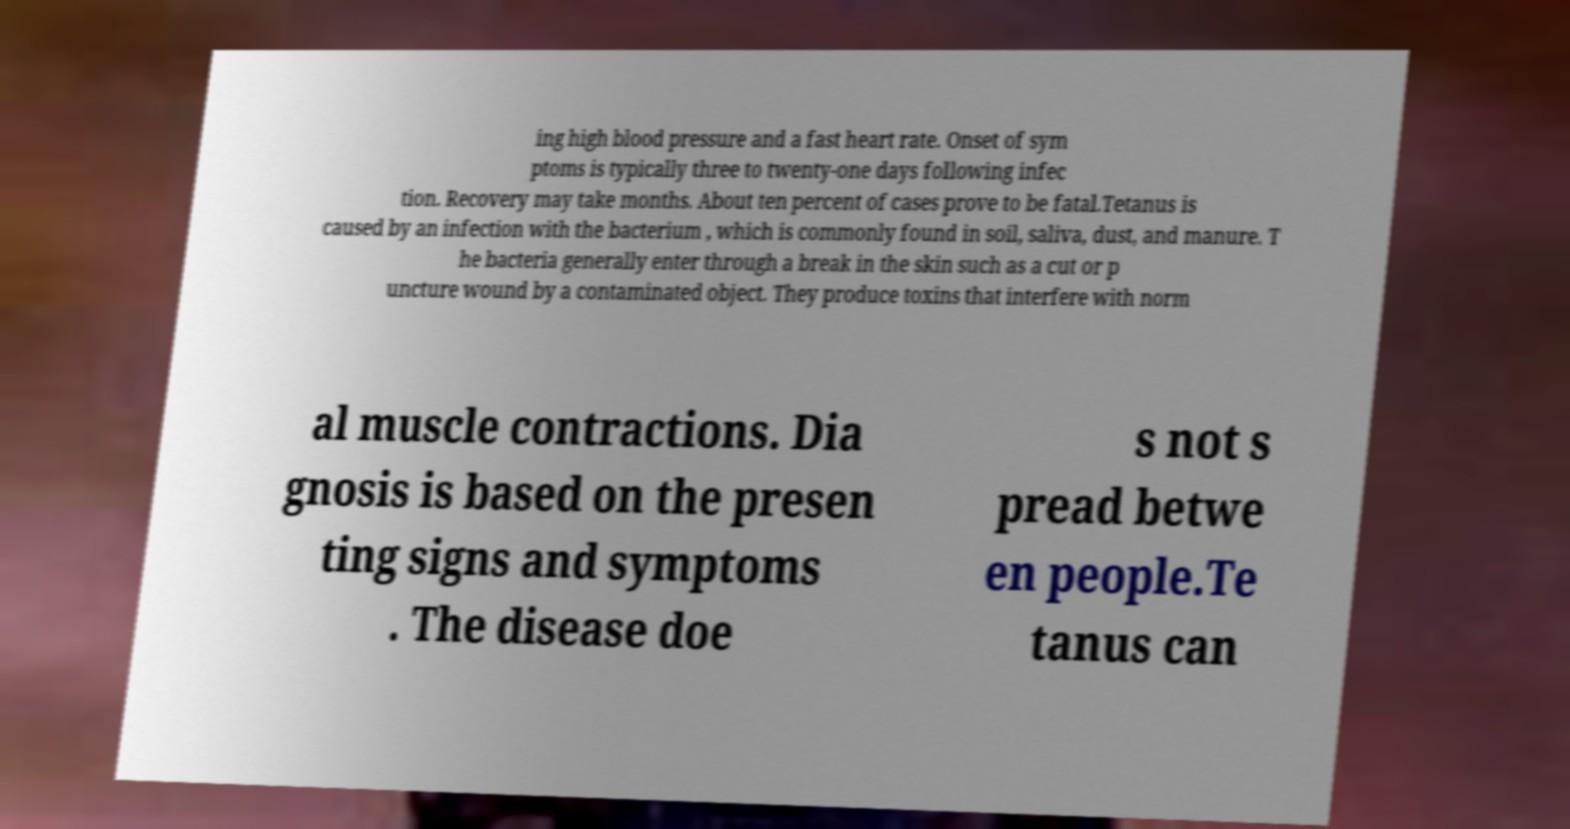There's text embedded in this image that I need extracted. Can you transcribe it verbatim? ing high blood pressure and a fast heart rate. Onset of sym ptoms is typically three to twenty-one days following infec tion. Recovery may take months. About ten percent of cases prove to be fatal.Tetanus is caused by an infection with the bacterium , which is commonly found in soil, saliva, dust, and manure. T he bacteria generally enter through a break in the skin such as a cut or p uncture wound by a contaminated object. They produce toxins that interfere with norm al muscle contractions. Dia gnosis is based on the presen ting signs and symptoms . The disease doe s not s pread betwe en people.Te tanus can 